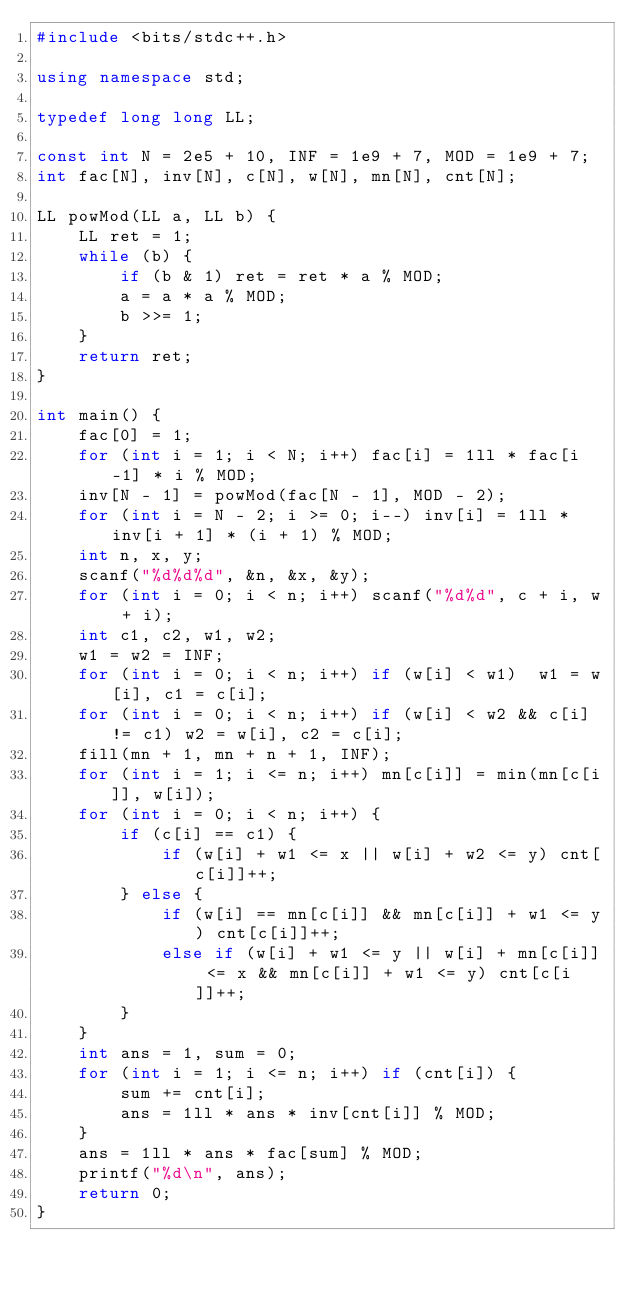Convert code to text. <code><loc_0><loc_0><loc_500><loc_500><_C++_>#include <bits/stdc++.h>

using namespace std;

typedef long long LL;

const int N = 2e5 + 10, INF = 1e9 + 7, MOD = 1e9 + 7;
int fac[N], inv[N], c[N], w[N], mn[N], cnt[N];

LL powMod(LL a, LL b) {
    LL ret = 1;
    while (b) {
        if (b & 1) ret = ret * a % MOD;
        a = a * a % MOD;
        b >>= 1;
    }
    return ret;
}

int main() {
    fac[0] = 1;
    for (int i = 1; i < N; i++) fac[i] = 1ll * fac[i-1] * i % MOD;
    inv[N - 1] = powMod(fac[N - 1], MOD - 2);
    for (int i = N - 2; i >= 0; i--) inv[i] = 1ll * inv[i + 1] * (i + 1) % MOD;
    int n, x, y;
    scanf("%d%d%d", &n, &x, &y);
    for (int i = 0; i < n; i++) scanf("%d%d", c + i, w + i);
    int c1, c2, w1, w2;
    w1 = w2 = INF;
    for (int i = 0; i < n; i++) if (w[i] < w1)  w1 = w[i], c1 = c[i];
    for (int i = 0; i < n; i++) if (w[i] < w2 && c[i] != c1) w2 = w[i], c2 = c[i];
    fill(mn + 1, mn + n + 1, INF);
    for (int i = 1; i <= n; i++) mn[c[i]] = min(mn[c[i]], w[i]);
    for (int i = 0; i < n; i++) {
        if (c[i] == c1) {
            if (w[i] + w1 <= x || w[i] + w2 <= y) cnt[c[i]]++;
        } else {
            if (w[i] == mn[c[i]] && mn[c[i]] + w1 <= y) cnt[c[i]]++;
            else if (w[i] + w1 <= y || w[i] + mn[c[i]] <= x && mn[c[i]] + w1 <= y) cnt[c[i]]++;
        }
    }
    int ans = 1, sum = 0;
    for (int i = 1; i <= n; i++) if (cnt[i]) {
        sum += cnt[i];
        ans = 1ll * ans * inv[cnt[i]] % MOD;
    }
    ans = 1ll * ans * fac[sum] % MOD;
    printf("%d\n", ans);
    return 0;
}
</code> 